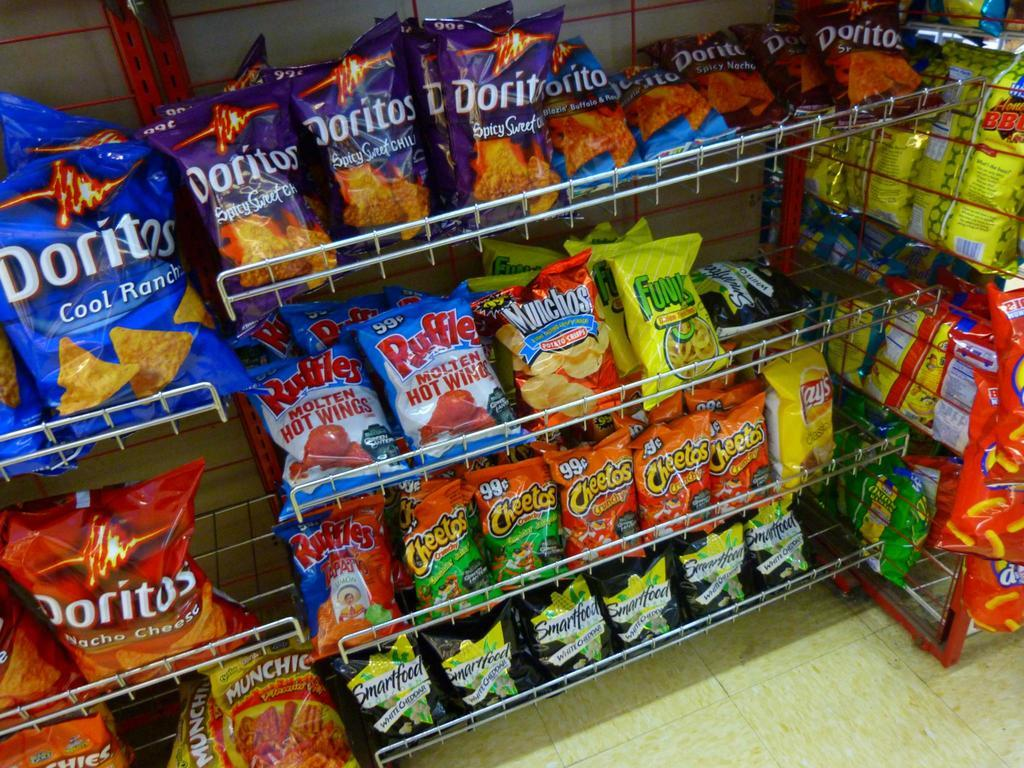<image>
Present a compact description of the photo's key features. Bags of chips are organized on shelves with the Flaming Hot Munchies in the bottom left. 